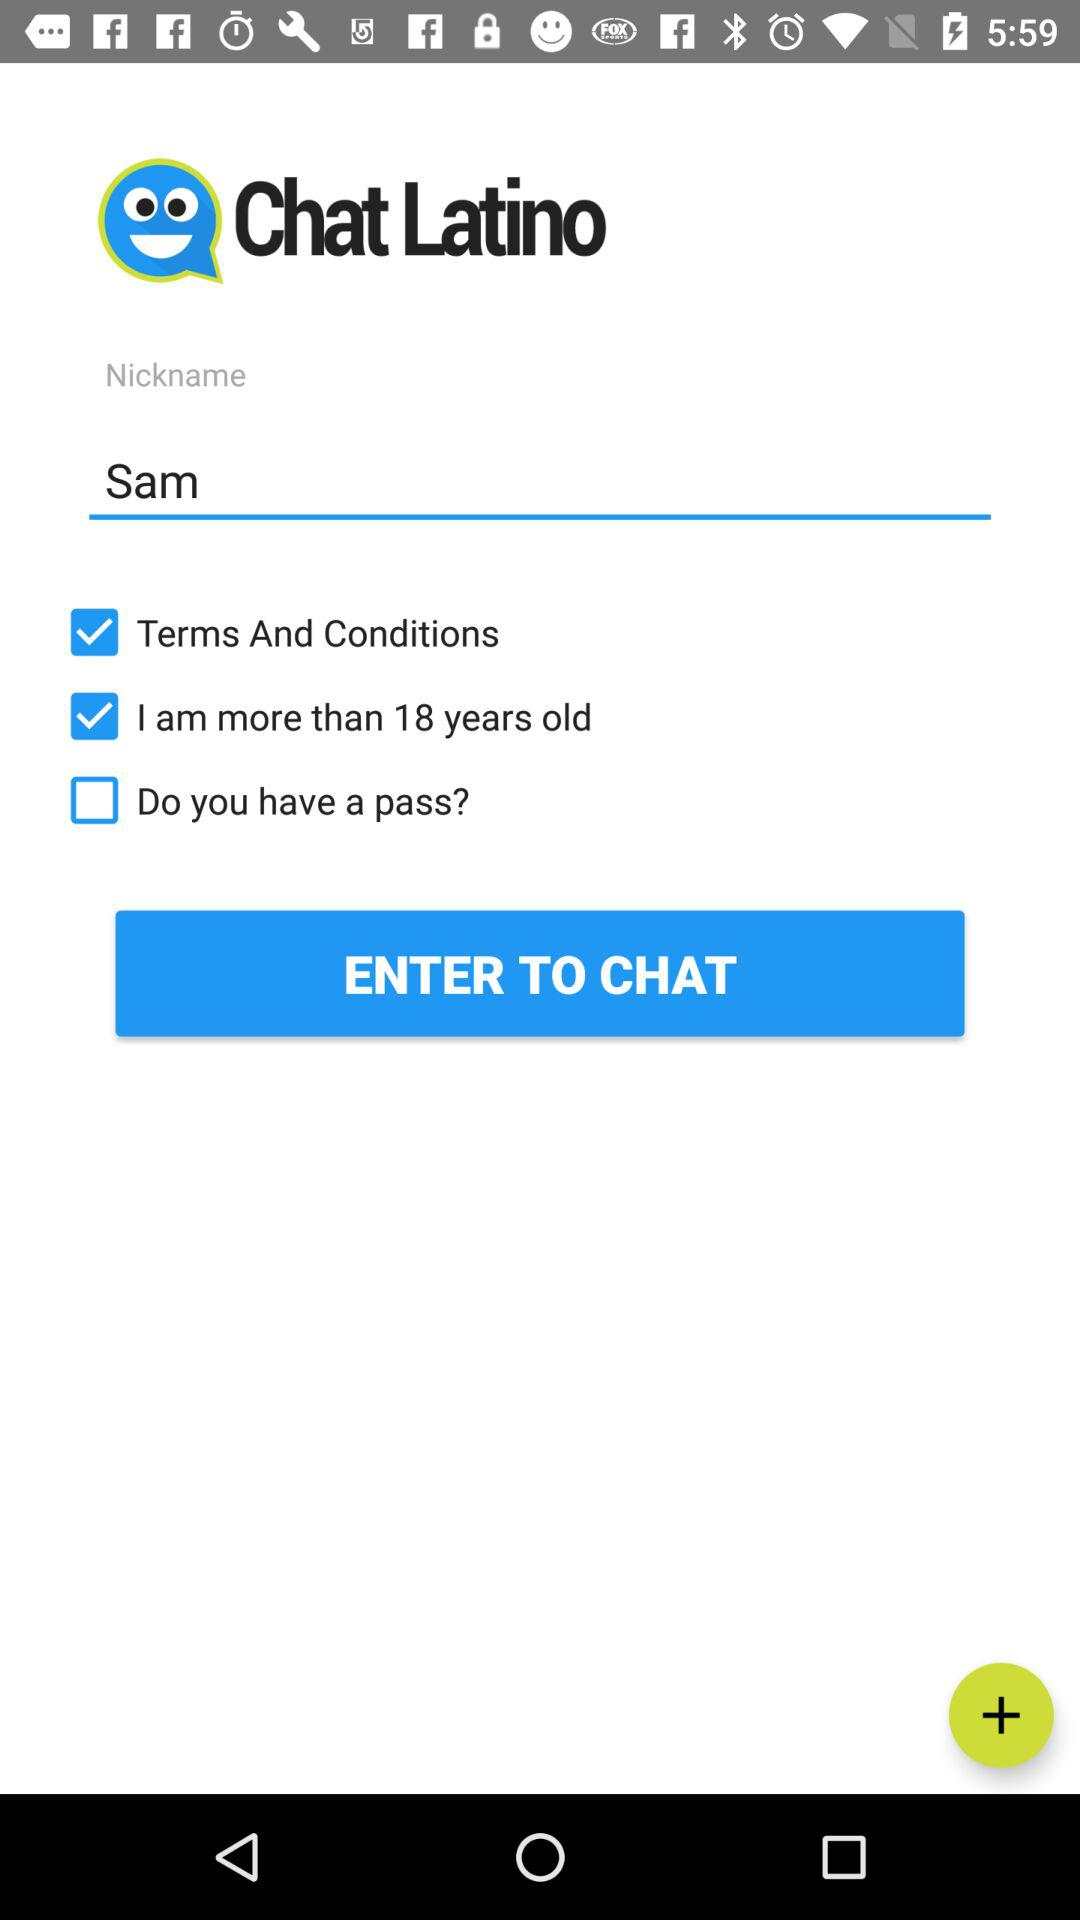How many more check boxes are there than text inputs?
Answer the question using a single word or phrase. 2 